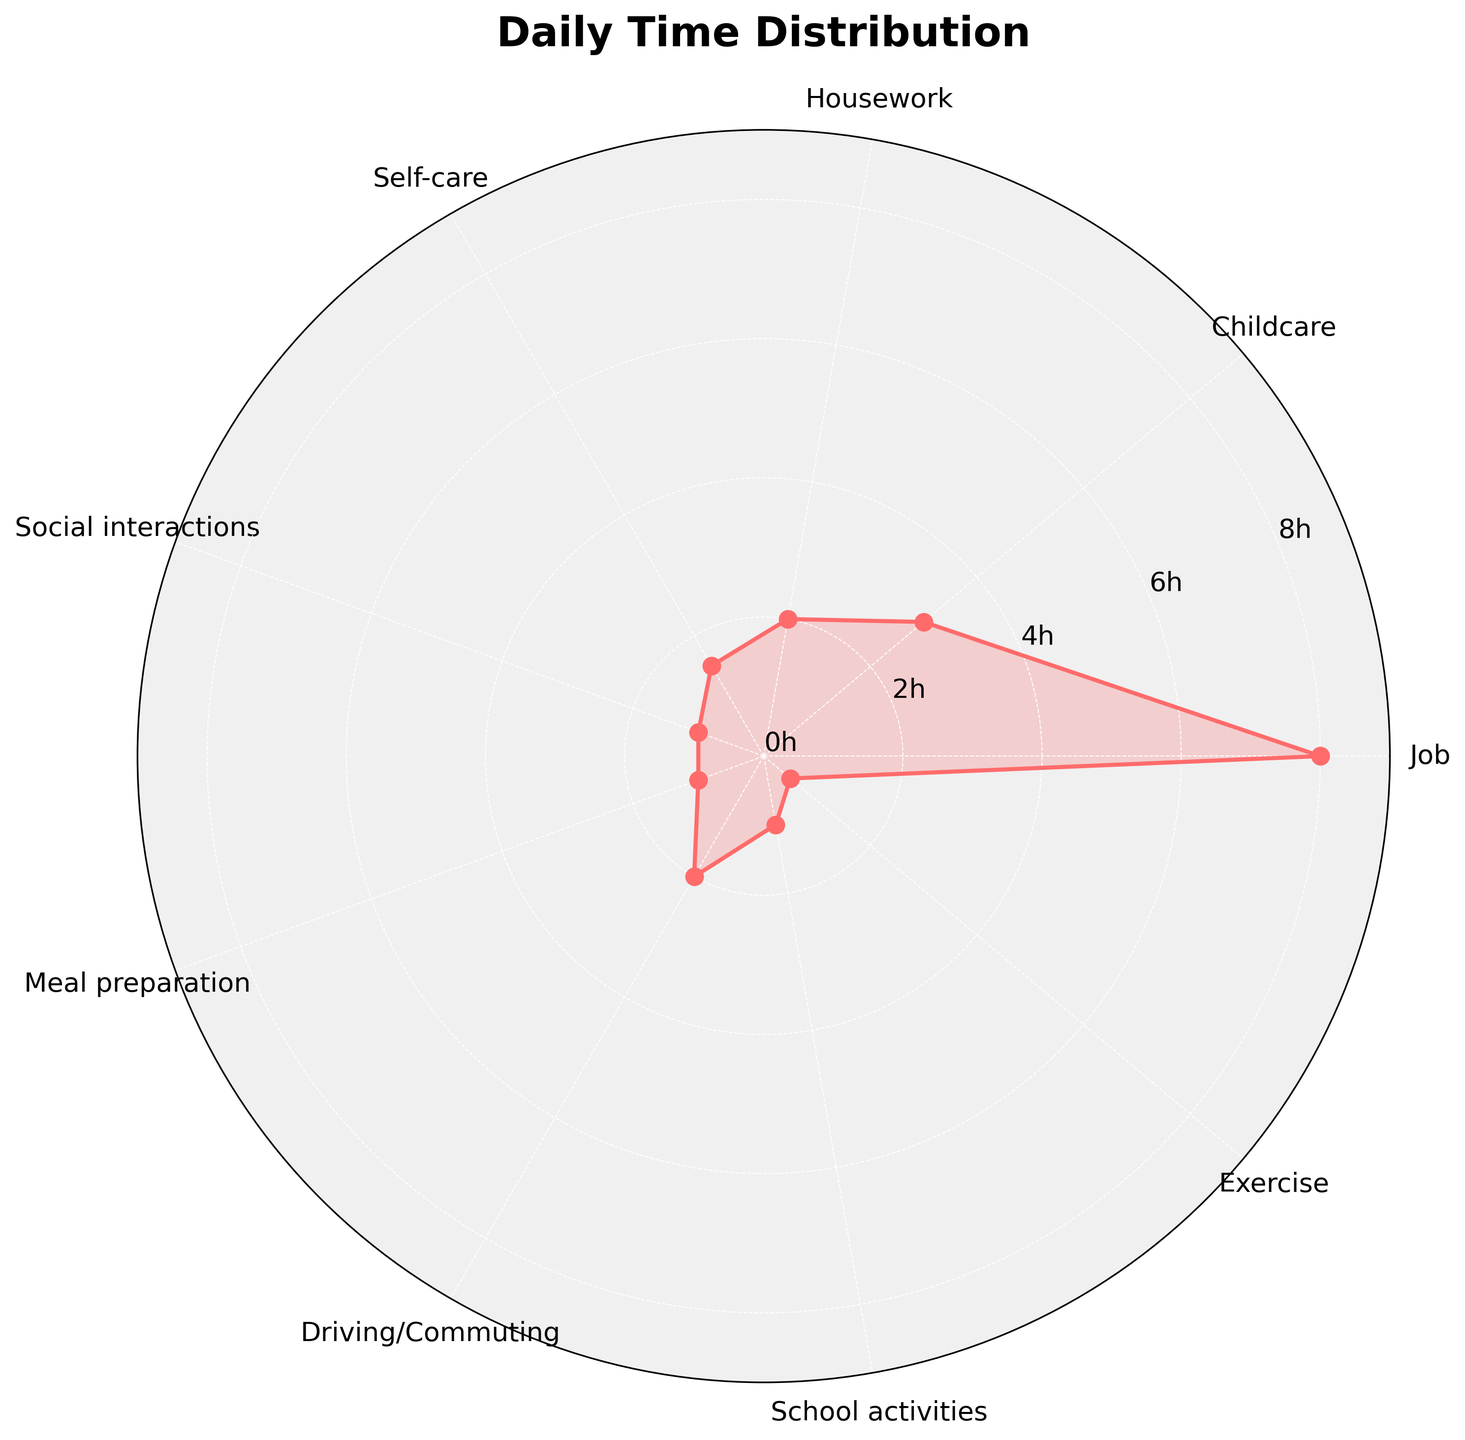What is the title of the figure? The title of the figure is at the top of the chart. It reads "Daily Time Distribution".
Answer: Daily Time Distribution Which activity has the maximum time spent on it daily? Looking at the chart, the activity with the highest value on the radial axis is "Job" with 8 hours.
Answer: Job How many hours are spent on childcare daily? On the polar chart, locate the "Childcare" label and then read the value on the radial axis that aligns with it. It shows 3 hours.
Answer: 3 hours What is the total time spent on meal preparation, self-care, and exercise combined? Add the hours for meal preparation (1), self-care (1.5), and exercise (0.5): 1 + 1.5 + 0.5 = 3
Answer: 3 hours Compare the time spent on driving/commuting and school activities. Which one is greater and by how much? The time spent on driving/commuting is 2 hours and on school activities is 1 hour. Calculate the difference: 2 - 1 = 1. Driving/commuting is greater by 1 hour.
Answer: Driving/commuting by 1 hour What is the average time spent on all activities daily? Sum the hours for all activities: 8 + 3 + 2 + 1.5 + 1 + 1 + 2 + 1 + 0.5 = 20. Divide by the number of activities: 20 / 9 ≈ 2.22.
Answer: ≈ 2.22 hours Which activity has the least amount of time spent on it daily? The smallest value on the radial axis corresponds to "Exercise," which is 0.5 hours.
Answer: Exercise How does the time spent on job compare to that spent on housework daily? Time spent on job is 8 hours while housework is 2 hours. Job time is greater and the difference is 8 - 2 = 6 hours.
Answer: Job by 6 hours What is the total time spent on childcare and social interactions? Add the hours for childcare (3) and social interactions (1): 3 + 1 = 4
Answer: 4 hours 